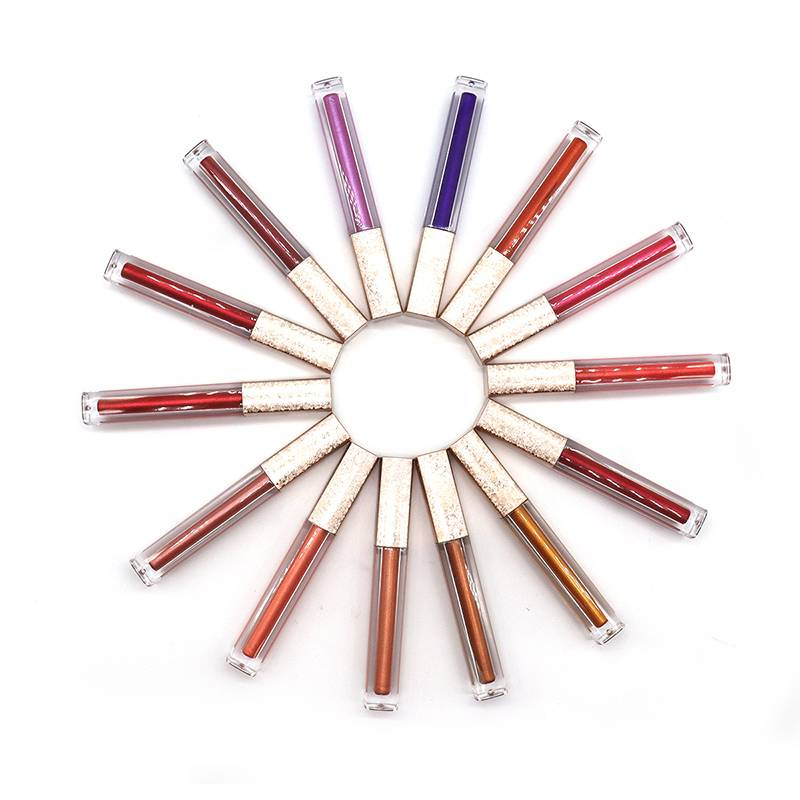Considering the arrangement and visible shades of the lip gloss tubes, which two tubes, when combined, would likely create a new shade that is not already presented among the existing tubes? If we were to take artistic liberties and experiment with color mixing based on the visible shades of these lip gloss tubes, blending the contents of the tube with a light pastel pink hue and a tube with a rich, saturated purple could yield an intriguing new color. Such a combination might produce a subtle mauve or an elegant dusty rose, absent from the current collection. It would be a harmonious blend, embodying a soft, romantic vibe, and adding a nuanced addition to the palette. Still, it's important to mention that the true outcome would depend on the specific pigments and opacity of the individual glosses, which we cannot fully assess from the image alone. 